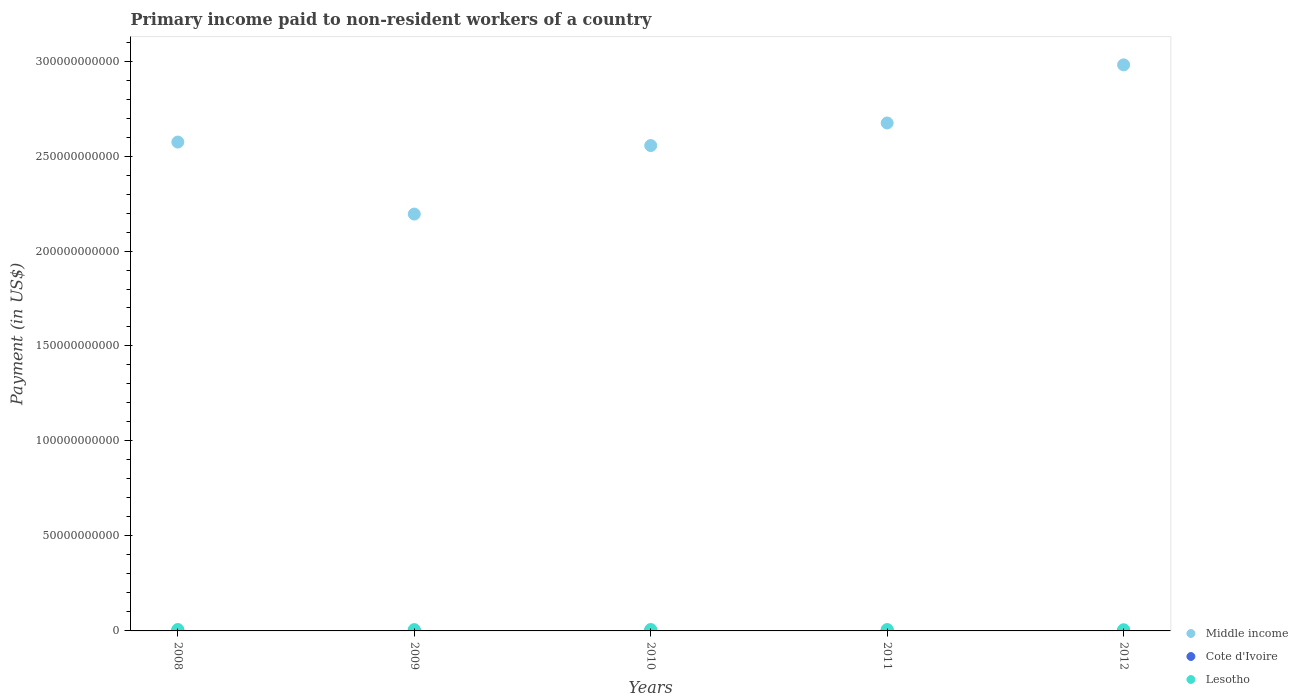Is the number of dotlines equal to the number of legend labels?
Provide a succinct answer. Yes. What is the amount paid to workers in Lesotho in 2009?
Provide a succinct answer. 6.98e+08. Across all years, what is the maximum amount paid to workers in Middle income?
Your answer should be very brief. 2.98e+11. Across all years, what is the minimum amount paid to workers in Middle income?
Keep it short and to the point. 2.19e+11. In which year was the amount paid to workers in Cote d'Ivoire maximum?
Give a very brief answer. 2008. What is the total amount paid to workers in Lesotho in the graph?
Your answer should be very brief. 3.54e+09. What is the difference between the amount paid to workers in Middle income in 2008 and that in 2009?
Provide a short and direct response. 3.79e+1. What is the difference between the amount paid to workers in Cote d'Ivoire in 2009 and the amount paid to workers in Middle income in 2010?
Make the answer very short. -2.55e+11. What is the average amount paid to workers in Middle income per year?
Give a very brief answer. 2.60e+11. In the year 2010, what is the difference between the amount paid to workers in Cote d'Ivoire and amount paid to workers in Lesotho?
Offer a terse response. -5.27e+08. In how many years, is the amount paid to workers in Middle income greater than 270000000000 US$?
Your answer should be very brief. 1. What is the ratio of the amount paid to workers in Lesotho in 2008 to that in 2010?
Provide a short and direct response. 1.01. What is the difference between the highest and the second highest amount paid to workers in Lesotho?
Make the answer very short. 4.59e+06. What is the difference between the highest and the lowest amount paid to workers in Cote d'Ivoire?
Your answer should be very brief. 2.90e+07. In how many years, is the amount paid to workers in Cote d'Ivoire greater than the average amount paid to workers in Cote d'Ivoire taken over all years?
Offer a very short reply. 2. Is the sum of the amount paid to workers in Cote d'Ivoire in 2009 and 2010 greater than the maximum amount paid to workers in Lesotho across all years?
Offer a terse response. No. Is it the case that in every year, the sum of the amount paid to workers in Lesotho and amount paid to workers in Cote d'Ivoire  is greater than the amount paid to workers in Middle income?
Offer a very short reply. No. Is the amount paid to workers in Cote d'Ivoire strictly less than the amount paid to workers in Lesotho over the years?
Keep it short and to the point. Yes. How many dotlines are there?
Your answer should be very brief. 3. How many years are there in the graph?
Give a very brief answer. 5. What is the difference between two consecutive major ticks on the Y-axis?
Make the answer very short. 5.00e+1. Does the graph contain any zero values?
Provide a short and direct response. No. How are the legend labels stacked?
Your answer should be compact. Vertical. What is the title of the graph?
Your answer should be very brief. Primary income paid to non-resident workers of a country. What is the label or title of the Y-axis?
Your response must be concise. Payment (in US$). What is the Payment (in US$) of Middle income in 2008?
Make the answer very short. 2.57e+11. What is the Payment (in US$) in Cote d'Ivoire in 2008?
Keep it short and to the point. 2.37e+08. What is the Payment (in US$) in Lesotho in 2008?
Offer a very short reply. 7.48e+08. What is the Payment (in US$) in Middle income in 2009?
Your answer should be compact. 2.19e+11. What is the Payment (in US$) of Cote d'Ivoire in 2009?
Keep it short and to the point. 2.22e+08. What is the Payment (in US$) of Lesotho in 2009?
Provide a succinct answer. 6.98e+08. What is the Payment (in US$) in Middle income in 2010?
Provide a succinct answer. 2.56e+11. What is the Payment (in US$) in Cote d'Ivoire in 2010?
Give a very brief answer. 2.17e+08. What is the Payment (in US$) of Lesotho in 2010?
Your answer should be very brief. 7.44e+08. What is the Payment (in US$) in Middle income in 2011?
Your answer should be very brief. 2.67e+11. What is the Payment (in US$) of Cote d'Ivoire in 2011?
Give a very brief answer. 2.08e+08. What is the Payment (in US$) in Lesotho in 2011?
Offer a very short reply. 7.27e+08. What is the Payment (in US$) of Middle income in 2012?
Offer a terse response. 2.98e+11. What is the Payment (in US$) of Cote d'Ivoire in 2012?
Your answer should be very brief. 2.08e+08. What is the Payment (in US$) of Lesotho in 2012?
Make the answer very short. 6.18e+08. Across all years, what is the maximum Payment (in US$) in Middle income?
Ensure brevity in your answer.  2.98e+11. Across all years, what is the maximum Payment (in US$) in Cote d'Ivoire?
Make the answer very short. 2.37e+08. Across all years, what is the maximum Payment (in US$) of Lesotho?
Your answer should be compact. 7.48e+08. Across all years, what is the minimum Payment (in US$) in Middle income?
Your response must be concise. 2.19e+11. Across all years, what is the minimum Payment (in US$) of Cote d'Ivoire?
Make the answer very short. 2.08e+08. Across all years, what is the minimum Payment (in US$) in Lesotho?
Ensure brevity in your answer.  6.18e+08. What is the total Payment (in US$) of Middle income in the graph?
Keep it short and to the point. 1.30e+12. What is the total Payment (in US$) in Cote d'Ivoire in the graph?
Offer a terse response. 1.09e+09. What is the total Payment (in US$) in Lesotho in the graph?
Offer a very short reply. 3.54e+09. What is the difference between the Payment (in US$) in Middle income in 2008 and that in 2009?
Your answer should be compact. 3.79e+1. What is the difference between the Payment (in US$) of Cote d'Ivoire in 2008 and that in 2009?
Provide a short and direct response. 1.47e+07. What is the difference between the Payment (in US$) of Lesotho in 2008 and that in 2009?
Ensure brevity in your answer.  5.05e+07. What is the difference between the Payment (in US$) of Middle income in 2008 and that in 2010?
Provide a short and direct response. 1.83e+09. What is the difference between the Payment (in US$) of Cote d'Ivoire in 2008 and that in 2010?
Offer a terse response. 1.93e+07. What is the difference between the Payment (in US$) in Lesotho in 2008 and that in 2010?
Give a very brief answer. 4.59e+06. What is the difference between the Payment (in US$) in Middle income in 2008 and that in 2011?
Your answer should be very brief. -1.00e+1. What is the difference between the Payment (in US$) in Cote d'Ivoire in 2008 and that in 2011?
Make the answer very short. 2.90e+07. What is the difference between the Payment (in US$) of Lesotho in 2008 and that in 2011?
Give a very brief answer. 2.14e+07. What is the difference between the Payment (in US$) of Middle income in 2008 and that in 2012?
Provide a succinct answer. -4.06e+1. What is the difference between the Payment (in US$) in Cote d'Ivoire in 2008 and that in 2012?
Keep it short and to the point. 2.89e+07. What is the difference between the Payment (in US$) of Lesotho in 2008 and that in 2012?
Give a very brief answer. 1.31e+08. What is the difference between the Payment (in US$) of Middle income in 2009 and that in 2010?
Provide a short and direct response. -3.61e+1. What is the difference between the Payment (in US$) in Cote d'Ivoire in 2009 and that in 2010?
Provide a succinct answer. 4.60e+06. What is the difference between the Payment (in US$) in Lesotho in 2009 and that in 2010?
Offer a terse response. -4.59e+07. What is the difference between the Payment (in US$) of Middle income in 2009 and that in 2011?
Provide a short and direct response. -4.80e+1. What is the difference between the Payment (in US$) of Cote d'Ivoire in 2009 and that in 2011?
Provide a short and direct response. 1.43e+07. What is the difference between the Payment (in US$) of Lesotho in 2009 and that in 2011?
Provide a short and direct response. -2.91e+07. What is the difference between the Payment (in US$) of Middle income in 2009 and that in 2012?
Your response must be concise. -7.86e+1. What is the difference between the Payment (in US$) in Cote d'Ivoire in 2009 and that in 2012?
Ensure brevity in your answer.  1.42e+07. What is the difference between the Payment (in US$) of Lesotho in 2009 and that in 2012?
Provide a succinct answer. 8.03e+07. What is the difference between the Payment (in US$) of Middle income in 2010 and that in 2011?
Ensure brevity in your answer.  -1.19e+1. What is the difference between the Payment (in US$) in Cote d'Ivoire in 2010 and that in 2011?
Your answer should be compact. 9.68e+06. What is the difference between the Payment (in US$) in Lesotho in 2010 and that in 2011?
Keep it short and to the point. 1.68e+07. What is the difference between the Payment (in US$) of Middle income in 2010 and that in 2012?
Ensure brevity in your answer.  -4.25e+1. What is the difference between the Payment (in US$) of Cote d'Ivoire in 2010 and that in 2012?
Keep it short and to the point. 9.57e+06. What is the difference between the Payment (in US$) of Lesotho in 2010 and that in 2012?
Provide a succinct answer. 1.26e+08. What is the difference between the Payment (in US$) of Middle income in 2011 and that in 2012?
Provide a succinct answer. -3.06e+1. What is the difference between the Payment (in US$) of Cote d'Ivoire in 2011 and that in 2012?
Offer a very short reply. -1.12e+05. What is the difference between the Payment (in US$) of Lesotho in 2011 and that in 2012?
Offer a very short reply. 1.09e+08. What is the difference between the Payment (in US$) of Middle income in 2008 and the Payment (in US$) of Cote d'Ivoire in 2009?
Your answer should be compact. 2.57e+11. What is the difference between the Payment (in US$) in Middle income in 2008 and the Payment (in US$) in Lesotho in 2009?
Your answer should be compact. 2.57e+11. What is the difference between the Payment (in US$) of Cote d'Ivoire in 2008 and the Payment (in US$) of Lesotho in 2009?
Make the answer very short. -4.61e+08. What is the difference between the Payment (in US$) of Middle income in 2008 and the Payment (in US$) of Cote d'Ivoire in 2010?
Your response must be concise. 2.57e+11. What is the difference between the Payment (in US$) in Middle income in 2008 and the Payment (in US$) in Lesotho in 2010?
Provide a short and direct response. 2.57e+11. What is the difference between the Payment (in US$) in Cote d'Ivoire in 2008 and the Payment (in US$) in Lesotho in 2010?
Provide a succinct answer. -5.07e+08. What is the difference between the Payment (in US$) in Middle income in 2008 and the Payment (in US$) in Cote d'Ivoire in 2011?
Offer a very short reply. 2.57e+11. What is the difference between the Payment (in US$) of Middle income in 2008 and the Payment (in US$) of Lesotho in 2011?
Ensure brevity in your answer.  2.57e+11. What is the difference between the Payment (in US$) of Cote d'Ivoire in 2008 and the Payment (in US$) of Lesotho in 2011?
Provide a succinct answer. -4.90e+08. What is the difference between the Payment (in US$) in Middle income in 2008 and the Payment (in US$) in Cote d'Ivoire in 2012?
Ensure brevity in your answer.  2.57e+11. What is the difference between the Payment (in US$) in Middle income in 2008 and the Payment (in US$) in Lesotho in 2012?
Offer a very short reply. 2.57e+11. What is the difference between the Payment (in US$) of Cote d'Ivoire in 2008 and the Payment (in US$) of Lesotho in 2012?
Offer a very short reply. -3.81e+08. What is the difference between the Payment (in US$) of Middle income in 2009 and the Payment (in US$) of Cote d'Ivoire in 2010?
Offer a very short reply. 2.19e+11. What is the difference between the Payment (in US$) in Middle income in 2009 and the Payment (in US$) in Lesotho in 2010?
Offer a terse response. 2.19e+11. What is the difference between the Payment (in US$) in Cote d'Ivoire in 2009 and the Payment (in US$) in Lesotho in 2010?
Offer a very short reply. -5.22e+08. What is the difference between the Payment (in US$) in Middle income in 2009 and the Payment (in US$) in Cote d'Ivoire in 2011?
Ensure brevity in your answer.  2.19e+11. What is the difference between the Payment (in US$) of Middle income in 2009 and the Payment (in US$) of Lesotho in 2011?
Ensure brevity in your answer.  2.19e+11. What is the difference between the Payment (in US$) of Cote d'Ivoire in 2009 and the Payment (in US$) of Lesotho in 2011?
Make the answer very short. -5.05e+08. What is the difference between the Payment (in US$) of Middle income in 2009 and the Payment (in US$) of Cote d'Ivoire in 2012?
Your answer should be very brief. 2.19e+11. What is the difference between the Payment (in US$) of Middle income in 2009 and the Payment (in US$) of Lesotho in 2012?
Give a very brief answer. 2.19e+11. What is the difference between the Payment (in US$) in Cote d'Ivoire in 2009 and the Payment (in US$) in Lesotho in 2012?
Offer a terse response. -3.96e+08. What is the difference between the Payment (in US$) in Middle income in 2010 and the Payment (in US$) in Cote d'Ivoire in 2011?
Your response must be concise. 2.55e+11. What is the difference between the Payment (in US$) of Middle income in 2010 and the Payment (in US$) of Lesotho in 2011?
Offer a terse response. 2.55e+11. What is the difference between the Payment (in US$) of Cote d'Ivoire in 2010 and the Payment (in US$) of Lesotho in 2011?
Keep it short and to the point. -5.10e+08. What is the difference between the Payment (in US$) of Middle income in 2010 and the Payment (in US$) of Cote d'Ivoire in 2012?
Provide a short and direct response. 2.55e+11. What is the difference between the Payment (in US$) of Middle income in 2010 and the Payment (in US$) of Lesotho in 2012?
Provide a short and direct response. 2.55e+11. What is the difference between the Payment (in US$) in Cote d'Ivoire in 2010 and the Payment (in US$) in Lesotho in 2012?
Make the answer very short. -4.00e+08. What is the difference between the Payment (in US$) of Middle income in 2011 and the Payment (in US$) of Cote d'Ivoire in 2012?
Give a very brief answer. 2.67e+11. What is the difference between the Payment (in US$) of Middle income in 2011 and the Payment (in US$) of Lesotho in 2012?
Give a very brief answer. 2.67e+11. What is the difference between the Payment (in US$) of Cote d'Ivoire in 2011 and the Payment (in US$) of Lesotho in 2012?
Provide a short and direct response. -4.10e+08. What is the average Payment (in US$) of Middle income per year?
Provide a succinct answer. 2.60e+11. What is the average Payment (in US$) in Cote d'Ivoire per year?
Your answer should be very brief. 2.18e+08. What is the average Payment (in US$) in Lesotho per year?
Your answer should be compact. 7.07e+08. In the year 2008, what is the difference between the Payment (in US$) of Middle income and Payment (in US$) of Cote d'Ivoire?
Your response must be concise. 2.57e+11. In the year 2008, what is the difference between the Payment (in US$) of Middle income and Payment (in US$) of Lesotho?
Ensure brevity in your answer.  2.57e+11. In the year 2008, what is the difference between the Payment (in US$) of Cote d'Ivoire and Payment (in US$) of Lesotho?
Your response must be concise. -5.12e+08. In the year 2009, what is the difference between the Payment (in US$) in Middle income and Payment (in US$) in Cote d'Ivoire?
Provide a short and direct response. 2.19e+11. In the year 2009, what is the difference between the Payment (in US$) of Middle income and Payment (in US$) of Lesotho?
Give a very brief answer. 2.19e+11. In the year 2009, what is the difference between the Payment (in US$) in Cote d'Ivoire and Payment (in US$) in Lesotho?
Keep it short and to the point. -4.76e+08. In the year 2010, what is the difference between the Payment (in US$) in Middle income and Payment (in US$) in Cote d'Ivoire?
Ensure brevity in your answer.  2.55e+11. In the year 2010, what is the difference between the Payment (in US$) in Middle income and Payment (in US$) in Lesotho?
Ensure brevity in your answer.  2.55e+11. In the year 2010, what is the difference between the Payment (in US$) in Cote d'Ivoire and Payment (in US$) in Lesotho?
Offer a very short reply. -5.27e+08. In the year 2011, what is the difference between the Payment (in US$) of Middle income and Payment (in US$) of Cote d'Ivoire?
Ensure brevity in your answer.  2.67e+11. In the year 2011, what is the difference between the Payment (in US$) of Middle income and Payment (in US$) of Lesotho?
Provide a succinct answer. 2.67e+11. In the year 2011, what is the difference between the Payment (in US$) of Cote d'Ivoire and Payment (in US$) of Lesotho?
Make the answer very short. -5.19e+08. In the year 2012, what is the difference between the Payment (in US$) of Middle income and Payment (in US$) of Cote d'Ivoire?
Offer a terse response. 2.98e+11. In the year 2012, what is the difference between the Payment (in US$) in Middle income and Payment (in US$) in Lesotho?
Provide a succinct answer. 2.97e+11. In the year 2012, what is the difference between the Payment (in US$) in Cote d'Ivoire and Payment (in US$) in Lesotho?
Give a very brief answer. -4.10e+08. What is the ratio of the Payment (in US$) of Middle income in 2008 to that in 2009?
Give a very brief answer. 1.17. What is the ratio of the Payment (in US$) in Cote d'Ivoire in 2008 to that in 2009?
Your answer should be compact. 1.07. What is the ratio of the Payment (in US$) of Lesotho in 2008 to that in 2009?
Keep it short and to the point. 1.07. What is the ratio of the Payment (in US$) of Cote d'Ivoire in 2008 to that in 2010?
Your response must be concise. 1.09. What is the ratio of the Payment (in US$) of Lesotho in 2008 to that in 2010?
Your response must be concise. 1.01. What is the ratio of the Payment (in US$) of Middle income in 2008 to that in 2011?
Provide a short and direct response. 0.96. What is the ratio of the Payment (in US$) of Cote d'Ivoire in 2008 to that in 2011?
Your response must be concise. 1.14. What is the ratio of the Payment (in US$) in Lesotho in 2008 to that in 2011?
Your answer should be very brief. 1.03. What is the ratio of the Payment (in US$) in Middle income in 2008 to that in 2012?
Give a very brief answer. 0.86. What is the ratio of the Payment (in US$) in Cote d'Ivoire in 2008 to that in 2012?
Keep it short and to the point. 1.14. What is the ratio of the Payment (in US$) of Lesotho in 2008 to that in 2012?
Give a very brief answer. 1.21. What is the ratio of the Payment (in US$) of Middle income in 2009 to that in 2010?
Keep it short and to the point. 0.86. What is the ratio of the Payment (in US$) in Cote d'Ivoire in 2009 to that in 2010?
Your answer should be compact. 1.02. What is the ratio of the Payment (in US$) in Lesotho in 2009 to that in 2010?
Give a very brief answer. 0.94. What is the ratio of the Payment (in US$) in Middle income in 2009 to that in 2011?
Provide a succinct answer. 0.82. What is the ratio of the Payment (in US$) of Cote d'Ivoire in 2009 to that in 2011?
Provide a short and direct response. 1.07. What is the ratio of the Payment (in US$) in Lesotho in 2009 to that in 2011?
Provide a short and direct response. 0.96. What is the ratio of the Payment (in US$) of Middle income in 2009 to that in 2012?
Your answer should be compact. 0.74. What is the ratio of the Payment (in US$) in Cote d'Ivoire in 2009 to that in 2012?
Offer a terse response. 1.07. What is the ratio of the Payment (in US$) in Lesotho in 2009 to that in 2012?
Keep it short and to the point. 1.13. What is the ratio of the Payment (in US$) in Middle income in 2010 to that in 2011?
Offer a terse response. 0.96. What is the ratio of the Payment (in US$) in Cote d'Ivoire in 2010 to that in 2011?
Offer a terse response. 1.05. What is the ratio of the Payment (in US$) of Lesotho in 2010 to that in 2011?
Give a very brief answer. 1.02. What is the ratio of the Payment (in US$) of Middle income in 2010 to that in 2012?
Your answer should be very brief. 0.86. What is the ratio of the Payment (in US$) in Cote d'Ivoire in 2010 to that in 2012?
Provide a succinct answer. 1.05. What is the ratio of the Payment (in US$) of Lesotho in 2010 to that in 2012?
Provide a short and direct response. 1.2. What is the ratio of the Payment (in US$) in Middle income in 2011 to that in 2012?
Offer a terse response. 0.9. What is the ratio of the Payment (in US$) of Lesotho in 2011 to that in 2012?
Your answer should be compact. 1.18. What is the difference between the highest and the second highest Payment (in US$) of Middle income?
Offer a very short reply. 3.06e+1. What is the difference between the highest and the second highest Payment (in US$) in Cote d'Ivoire?
Your answer should be compact. 1.47e+07. What is the difference between the highest and the second highest Payment (in US$) in Lesotho?
Make the answer very short. 4.59e+06. What is the difference between the highest and the lowest Payment (in US$) of Middle income?
Give a very brief answer. 7.86e+1. What is the difference between the highest and the lowest Payment (in US$) in Cote d'Ivoire?
Provide a short and direct response. 2.90e+07. What is the difference between the highest and the lowest Payment (in US$) in Lesotho?
Offer a very short reply. 1.31e+08. 